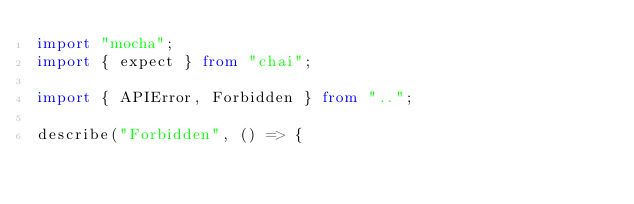<code> <loc_0><loc_0><loc_500><loc_500><_TypeScript_>import "mocha";
import { expect } from "chai";

import { APIError, Forbidden } from "..";

describe("Forbidden", () => {</code> 